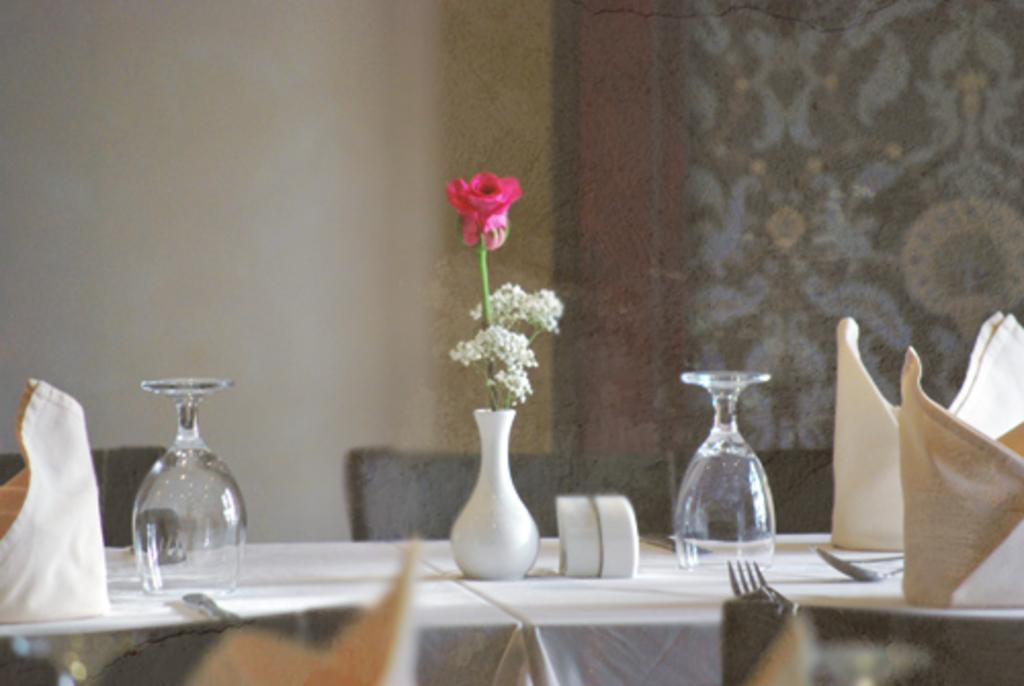Describe this image in one or two sentences. In the picture we can see a table, on the table we can see a glasses, flower vase with flower and tissues and we can also see some chairs beside the table and in the background we can see a wall with a wooden frame painting. 